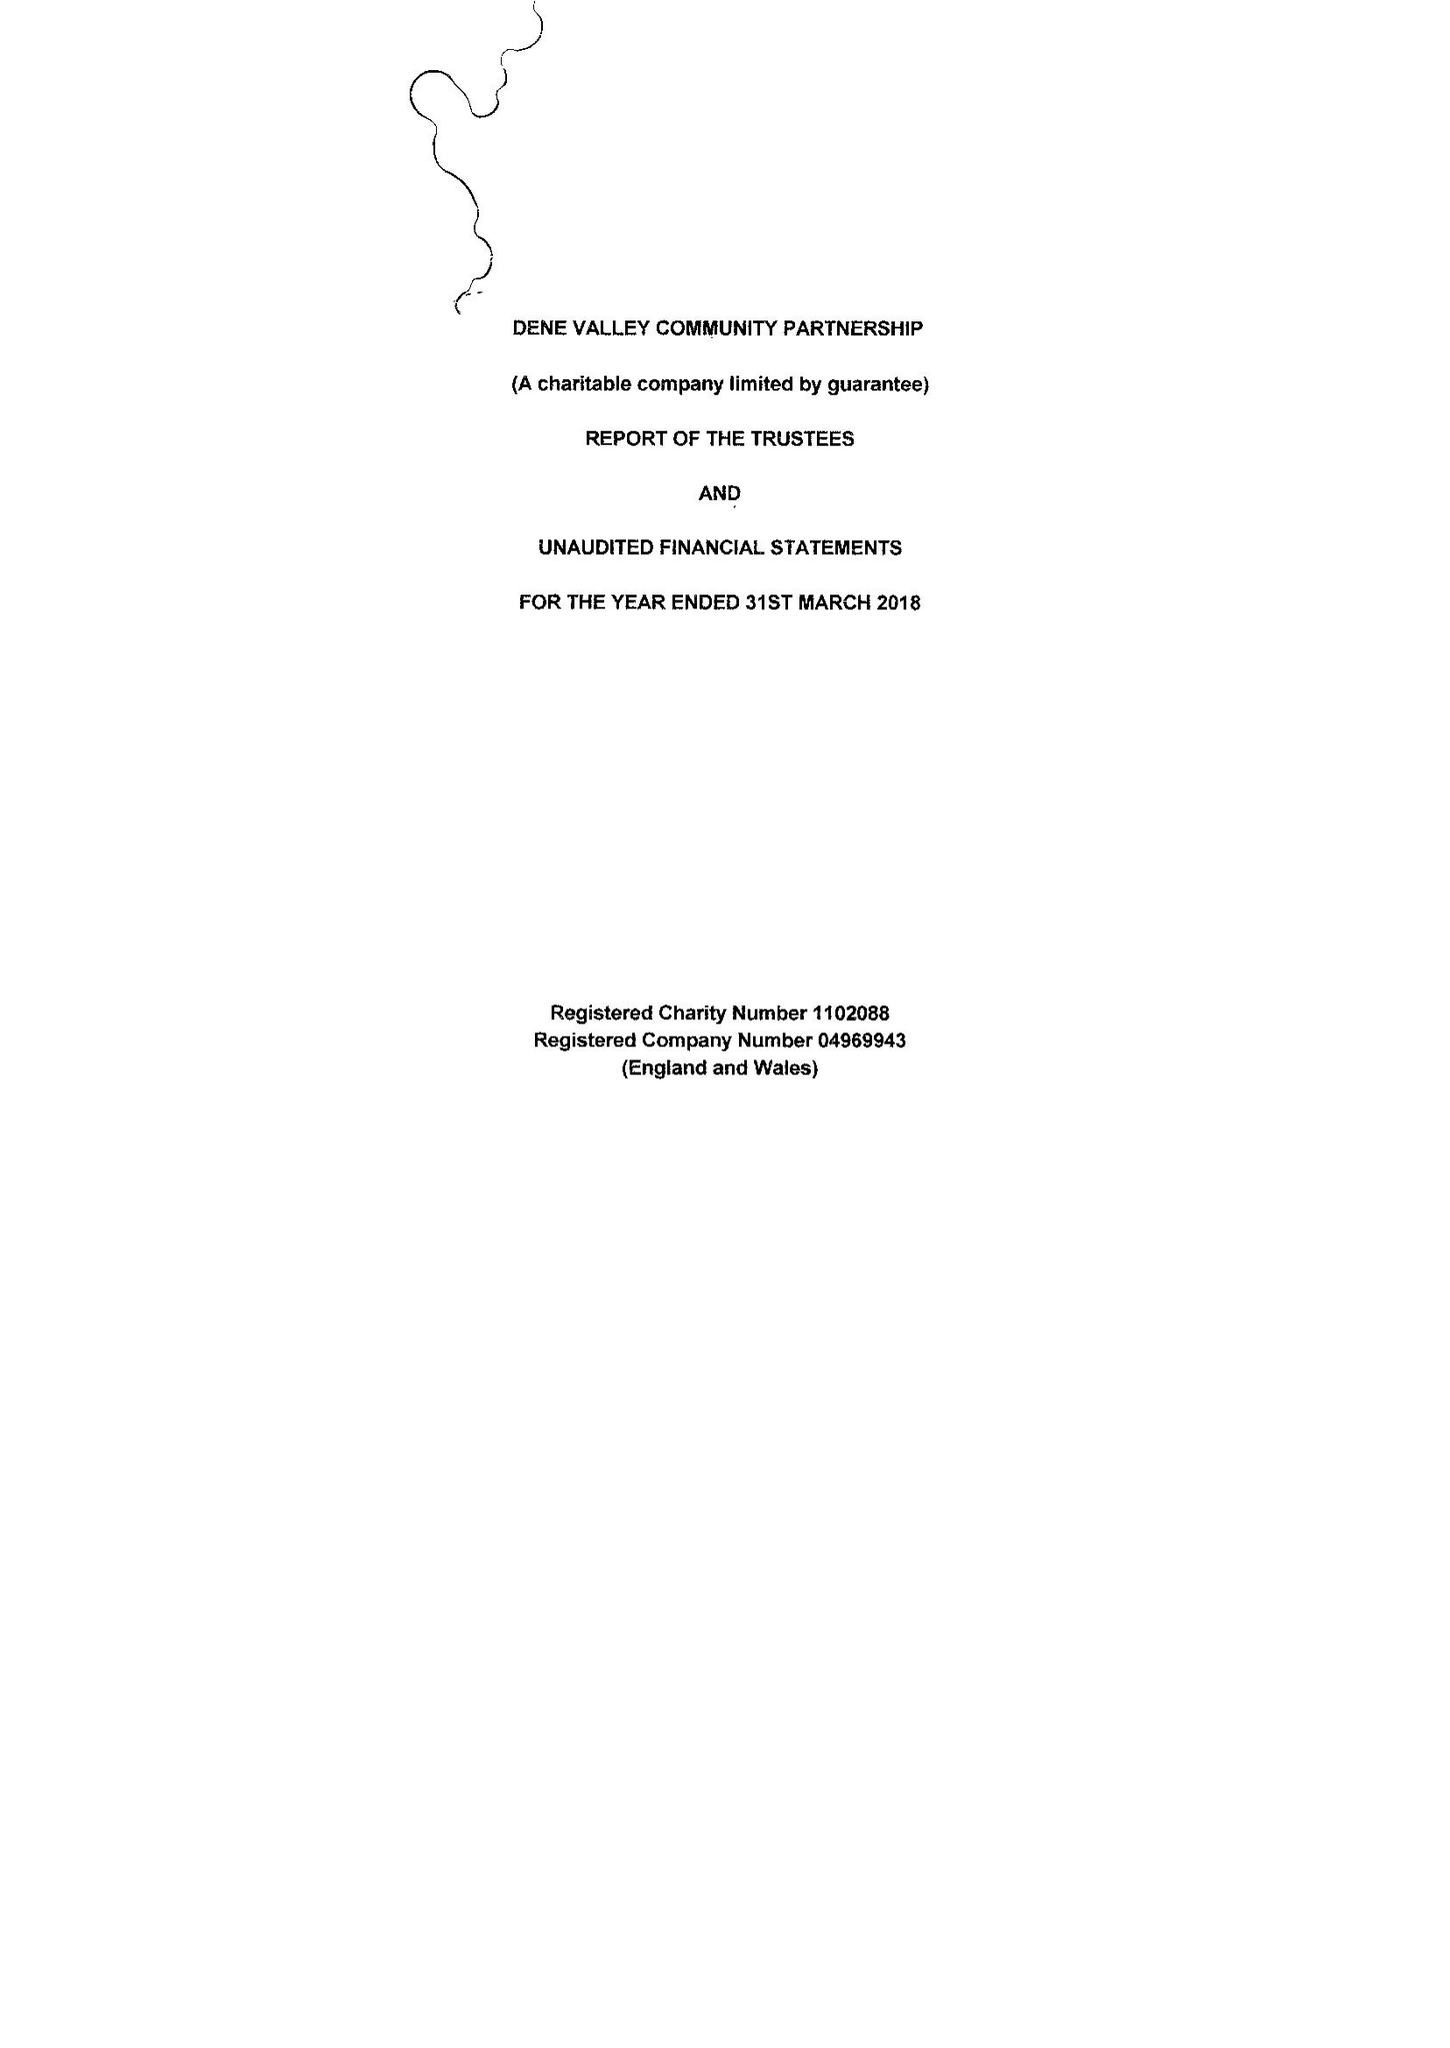What is the value for the charity_number?
Answer the question using a single word or phrase. 1102088 